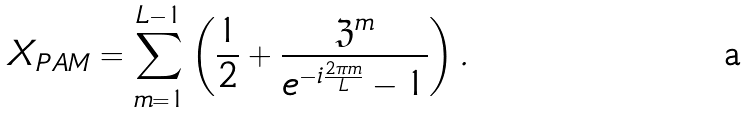Convert formula to latex. <formula><loc_0><loc_0><loc_500><loc_500>X _ { P A M } = \sum _ { m = 1 } ^ { L - 1 } \left ( \frac { 1 } { 2 } + \frac { { \mathfrak Z } ^ { m } } { e ^ { - i \frac { 2 \pi m } { L } } - 1 } \right ) .</formula> 